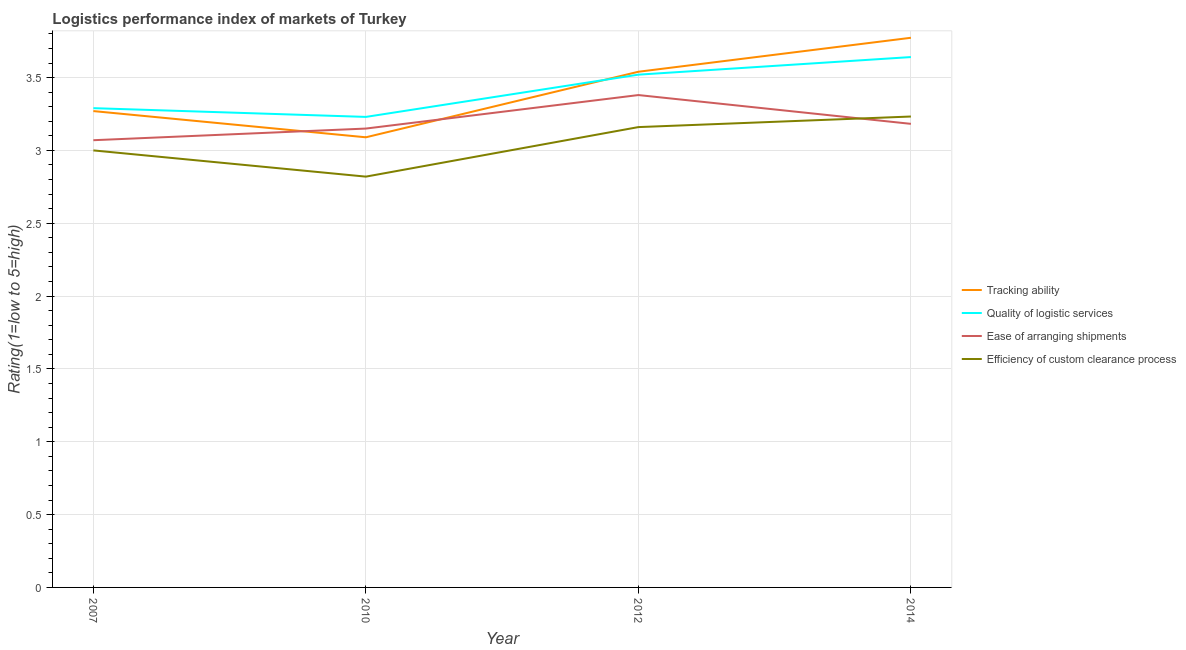Is the number of lines equal to the number of legend labels?
Your answer should be very brief. Yes. What is the lpi rating of efficiency of custom clearance process in 2012?
Offer a terse response. 3.16. Across all years, what is the maximum lpi rating of ease of arranging shipments?
Give a very brief answer. 3.38. Across all years, what is the minimum lpi rating of efficiency of custom clearance process?
Your answer should be compact. 2.82. In which year was the lpi rating of efficiency of custom clearance process maximum?
Offer a terse response. 2014. In which year was the lpi rating of quality of logistic services minimum?
Make the answer very short. 2010. What is the total lpi rating of quality of logistic services in the graph?
Provide a short and direct response. 13.68. What is the difference between the lpi rating of quality of logistic services in 2010 and that in 2012?
Make the answer very short. -0.29. What is the difference between the lpi rating of ease of arranging shipments in 2014 and the lpi rating of quality of logistic services in 2010?
Offer a very short reply. -0.05. What is the average lpi rating of ease of arranging shipments per year?
Your answer should be compact. 3.2. In the year 2014, what is the difference between the lpi rating of tracking ability and lpi rating of ease of arranging shipments?
Your answer should be compact. 0.59. What is the ratio of the lpi rating of ease of arranging shipments in 2010 to that in 2014?
Offer a terse response. 0.99. What is the difference between the highest and the second highest lpi rating of ease of arranging shipments?
Ensure brevity in your answer.  0.2. What is the difference between the highest and the lowest lpi rating of ease of arranging shipments?
Offer a terse response. 0.31. Is the sum of the lpi rating of ease of arranging shipments in 2007 and 2010 greater than the maximum lpi rating of quality of logistic services across all years?
Offer a terse response. Yes. Is it the case that in every year, the sum of the lpi rating of efficiency of custom clearance process and lpi rating of quality of logistic services is greater than the sum of lpi rating of tracking ability and lpi rating of ease of arranging shipments?
Your answer should be compact. No. Does the lpi rating of ease of arranging shipments monotonically increase over the years?
Ensure brevity in your answer.  No. How many lines are there?
Make the answer very short. 4. How many years are there in the graph?
Offer a terse response. 4. Are the values on the major ticks of Y-axis written in scientific E-notation?
Make the answer very short. No. Does the graph contain any zero values?
Give a very brief answer. No. Does the graph contain grids?
Your answer should be very brief. Yes. What is the title of the graph?
Offer a terse response. Logistics performance index of markets of Turkey. Does "Subsidies and Transfers" appear as one of the legend labels in the graph?
Keep it short and to the point. No. What is the label or title of the Y-axis?
Keep it short and to the point. Rating(1=low to 5=high). What is the Rating(1=low to 5=high) in Tracking ability in 2007?
Offer a terse response. 3.27. What is the Rating(1=low to 5=high) in Quality of logistic services in 2007?
Make the answer very short. 3.29. What is the Rating(1=low to 5=high) in Ease of arranging shipments in 2007?
Your response must be concise. 3.07. What is the Rating(1=low to 5=high) of Efficiency of custom clearance process in 2007?
Your answer should be compact. 3. What is the Rating(1=low to 5=high) in Tracking ability in 2010?
Offer a terse response. 3.09. What is the Rating(1=low to 5=high) in Quality of logistic services in 2010?
Your response must be concise. 3.23. What is the Rating(1=low to 5=high) of Ease of arranging shipments in 2010?
Provide a short and direct response. 3.15. What is the Rating(1=low to 5=high) of Efficiency of custom clearance process in 2010?
Provide a succinct answer. 2.82. What is the Rating(1=low to 5=high) in Tracking ability in 2012?
Keep it short and to the point. 3.54. What is the Rating(1=low to 5=high) in Quality of logistic services in 2012?
Offer a very short reply. 3.52. What is the Rating(1=low to 5=high) in Ease of arranging shipments in 2012?
Your answer should be very brief. 3.38. What is the Rating(1=low to 5=high) in Efficiency of custom clearance process in 2012?
Keep it short and to the point. 3.16. What is the Rating(1=low to 5=high) of Tracking ability in 2014?
Offer a terse response. 3.77. What is the Rating(1=low to 5=high) in Quality of logistic services in 2014?
Offer a very short reply. 3.64. What is the Rating(1=low to 5=high) in Ease of arranging shipments in 2014?
Your answer should be compact. 3.18. What is the Rating(1=low to 5=high) in Efficiency of custom clearance process in 2014?
Provide a short and direct response. 3.23. Across all years, what is the maximum Rating(1=low to 5=high) in Tracking ability?
Your response must be concise. 3.77. Across all years, what is the maximum Rating(1=low to 5=high) in Quality of logistic services?
Your response must be concise. 3.64. Across all years, what is the maximum Rating(1=low to 5=high) of Ease of arranging shipments?
Your answer should be very brief. 3.38. Across all years, what is the maximum Rating(1=low to 5=high) in Efficiency of custom clearance process?
Make the answer very short. 3.23. Across all years, what is the minimum Rating(1=low to 5=high) of Tracking ability?
Ensure brevity in your answer.  3.09. Across all years, what is the minimum Rating(1=low to 5=high) in Quality of logistic services?
Provide a short and direct response. 3.23. Across all years, what is the minimum Rating(1=low to 5=high) in Ease of arranging shipments?
Give a very brief answer. 3.07. Across all years, what is the minimum Rating(1=low to 5=high) in Efficiency of custom clearance process?
Offer a terse response. 2.82. What is the total Rating(1=low to 5=high) in Tracking ability in the graph?
Give a very brief answer. 13.67. What is the total Rating(1=low to 5=high) of Quality of logistic services in the graph?
Provide a succinct answer. 13.68. What is the total Rating(1=low to 5=high) of Ease of arranging shipments in the graph?
Offer a terse response. 12.78. What is the total Rating(1=low to 5=high) in Efficiency of custom clearance process in the graph?
Provide a succinct answer. 12.21. What is the difference between the Rating(1=low to 5=high) of Tracking ability in 2007 and that in 2010?
Provide a short and direct response. 0.18. What is the difference between the Rating(1=low to 5=high) in Quality of logistic services in 2007 and that in 2010?
Offer a very short reply. 0.06. What is the difference between the Rating(1=low to 5=high) in Ease of arranging shipments in 2007 and that in 2010?
Offer a terse response. -0.08. What is the difference between the Rating(1=low to 5=high) in Efficiency of custom clearance process in 2007 and that in 2010?
Keep it short and to the point. 0.18. What is the difference between the Rating(1=low to 5=high) of Tracking ability in 2007 and that in 2012?
Make the answer very short. -0.27. What is the difference between the Rating(1=low to 5=high) in Quality of logistic services in 2007 and that in 2012?
Offer a terse response. -0.23. What is the difference between the Rating(1=low to 5=high) in Ease of arranging shipments in 2007 and that in 2012?
Keep it short and to the point. -0.31. What is the difference between the Rating(1=low to 5=high) in Efficiency of custom clearance process in 2007 and that in 2012?
Your answer should be very brief. -0.16. What is the difference between the Rating(1=low to 5=high) in Tracking ability in 2007 and that in 2014?
Your answer should be compact. -0.5. What is the difference between the Rating(1=low to 5=high) of Quality of logistic services in 2007 and that in 2014?
Your answer should be very brief. -0.35. What is the difference between the Rating(1=low to 5=high) of Ease of arranging shipments in 2007 and that in 2014?
Your answer should be very brief. -0.11. What is the difference between the Rating(1=low to 5=high) in Efficiency of custom clearance process in 2007 and that in 2014?
Ensure brevity in your answer.  -0.23. What is the difference between the Rating(1=low to 5=high) in Tracking ability in 2010 and that in 2012?
Keep it short and to the point. -0.45. What is the difference between the Rating(1=low to 5=high) in Quality of logistic services in 2010 and that in 2012?
Keep it short and to the point. -0.29. What is the difference between the Rating(1=low to 5=high) of Ease of arranging shipments in 2010 and that in 2012?
Ensure brevity in your answer.  -0.23. What is the difference between the Rating(1=low to 5=high) in Efficiency of custom clearance process in 2010 and that in 2012?
Keep it short and to the point. -0.34. What is the difference between the Rating(1=low to 5=high) of Tracking ability in 2010 and that in 2014?
Make the answer very short. -0.68. What is the difference between the Rating(1=low to 5=high) in Quality of logistic services in 2010 and that in 2014?
Provide a succinct answer. -0.41. What is the difference between the Rating(1=low to 5=high) in Ease of arranging shipments in 2010 and that in 2014?
Your response must be concise. -0.03. What is the difference between the Rating(1=low to 5=high) in Efficiency of custom clearance process in 2010 and that in 2014?
Your answer should be very brief. -0.41. What is the difference between the Rating(1=low to 5=high) of Tracking ability in 2012 and that in 2014?
Offer a very short reply. -0.23. What is the difference between the Rating(1=low to 5=high) in Quality of logistic services in 2012 and that in 2014?
Your answer should be very brief. -0.12. What is the difference between the Rating(1=low to 5=high) in Ease of arranging shipments in 2012 and that in 2014?
Provide a succinct answer. 0.2. What is the difference between the Rating(1=low to 5=high) of Efficiency of custom clearance process in 2012 and that in 2014?
Ensure brevity in your answer.  -0.07. What is the difference between the Rating(1=low to 5=high) of Tracking ability in 2007 and the Rating(1=low to 5=high) of Ease of arranging shipments in 2010?
Your answer should be very brief. 0.12. What is the difference between the Rating(1=low to 5=high) in Tracking ability in 2007 and the Rating(1=low to 5=high) in Efficiency of custom clearance process in 2010?
Ensure brevity in your answer.  0.45. What is the difference between the Rating(1=low to 5=high) in Quality of logistic services in 2007 and the Rating(1=low to 5=high) in Ease of arranging shipments in 2010?
Your response must be concise. 0.14. What is the difference between the Rating(1=low to 5=high) in Quality of logistic services in 2007 and the Rating(1=low to 5=high) in Efficiency of custom clearance process in 2010?
Your answer should be compact. 0.47. What is the difference between the Rating(1=low to 5=high) of Ease of arranging shipments in 2007 and the Rating(1=low to 5=high) of Efficiency of custom clearance process in 2010?
Give a very brief answer. 0.25. What is the difference between the Rating(1=low to 5=high) in Tracking ability in 2007 and the Rating(1=low to 5=high) in Ease of arranging shipments in 2012?
Your response must be concise. -0.11. What is the difference between the Rating(1=low to 5=high) in Tracking ability in 2007 and the Rating(1=low to 5=high) in Efficiency of custom clearance process in 2012?
Provide a short and direct response. 0.11. What is the difference between the Rating(1=low to 5=high) in Quality of logistic services in 2007 and the Rating(1=low to 5=high) in Ease of arranging shipments in 2012?
Your answer should be compact. -0.09. What is the difference between the Rating(1=low to 5=high) in Quality of logistic services in 2007 and the Rating(1=low to 5=high) in Efficiency of custom clearance process in 2012?
Your answer should be very brief. 0.13. What is the difference between the Rating(1=low to 5=high) of Ease of arranging shipments in 2007 and the Rating(1=low to 5=high) of Efficiency of custom clearance process in 2012?
Make the answer very short. -0.09. What is the difference between the Rating(1=low to 5=high) of Tracking ability in 2007 and the Rating(1=low to 5=high) of Quality of logistic services in 2014?
Keep it short and to the point. -0.37. What is the difference between the Rating(1=low to 5=high) in Tracking ability in 2007 and the Rating(1=low to 5=high) in Ease of arranging shipments in 2014?
Provide a short and direct response. 0.09. What is the difference between the Rating(1=low to 5=high) of Tracking ability in 2007 and the Rating(1=low to 5=high) of Efficiency of custom clearance process in 2014?
Provide a succinct answer. 0.04. What is the difference between the Rating(1=low to 5=high) of Quality of logistic services in 2007 and the Rating(1=low to 5=high) of Ease of arranging shipments in 2014?
Keep it short and to the point. 0.11. What is the difference between the Rating(1=low to 5=high) in Quality of logistic services in 2007 and the Rating(1=low to 5=high) in Efficiency of custom clearance process in 2014?
Your answer should be compact. 0.06. What is the difference between the Rating(1=low to 5=high) in Ease of arranging shipments in 2007 and the Rating(1=low to 5=high) in Efficiency of custom clearance process in 2014?
Your answer should be very brief. -0.16. What is the difference between the Rating(1=low to 5=high) in Tracking ability in 2010 and the Rating(1=low to 5=high) in Quality of logistic services in 2012?
Offer a terse response. -0.43. What is the difference between the Rating(1=low to 5=high) of Tracking ability in 2010 and the Rating(1=low to 5=high) of Ease of arranging shipments in 2012?
Give a very brief answer. -0.29. What is the difference between the Rating(1=low to 5=high) in Tracking ability in 2010 and the Rating(1=low to 5=high) in Efficiency of custom clearance process in 2012?
Your answer should be very brief. -0.07. What is the difference between the Rating(1=low to 5=high) in Quality of logistic services in 2010 and the Rating(1=low to 5=high) in Efficiency of custom clearance process in 2012?
Keep it short and to the point. 0.07. What is the difference between the Rating(1=low to 5=high) of Ease of arranging shipments in 2010 and the Rating(1=low to 5=high) of Efficiency of custom clearance process in 2012?
Offer a very short reply. -0.01. What is the difference between the Rating(1=low to 5=high) of Tracking ability in 2010 and the Rating(1=low to 5=high) of Quality of logistic services in 2014?
Provide a succinct answer. -0.55. What is the difference between the Rating(1=low to 5=high) of Tracking ability in 2010 and the Rating(1=low to 5=high) of Ease of arranging shipments in 2014?
Ensure brevity in your answer.  -0.09. What is the difference between the Rating(1=low to 5=high) of Tracking ability in 2010 and the Rating(1=low to 5=high) of Efficiency of custom clearance process in 2014?
Give a very brief answer. -0.14. What is the difference between the Rating(1=low to 5=high) of Quality of logistic services in 2010 and the Rating(1=low to 5=high) of Ease of arranging shipments in 2014?
Offer a terse response. 0.05. What is the difference between the Rating(1=low to 5=high) in Quality of logistic services in 2010 and the Rating(1=low to 5=high) in Efficiency of custom clearance process in 2014?
Keep it short and to the point. -0. What is the difference between the Rating(1=low to 5=high) in Ease of arranging shipments in 2010 and the Rating(1=low to 5=high) in Efficiency of custom clearance process in 2014?
Your answer should be compact. -0.08. What is the difference between the Rating(1=low to 5=high) in Tracking ability in 2012 and the Rating(1=low to 5=high) in Quality of logistic services in 2014?
Give a very brief answer. -0.1. What is the difference between the Rating(1=low to 5=high) in Tracking ability in 2012 and the Rating(1=low to 5=high) in Ease of arranging shipments in 2014?
Offer a very short reply. 0.36. What is the difference between the Rating(1=low to 5=high) in Tracking ability in 2012 and the Rating(1=low to 5=high) in Efficiency of custom clearance process in 2014?
Offer a terse response. 0.31. What is the difference between the Rating(1=low to 5=high) of Quality of logistic services in 2012 and the Rating(1=low to 5=high) of Ease of arranging shipments in 2014?
Your answer should be very brief. 0.34. What is the difference between the Rating(1=low to 5=high) in Quality of logistic services in 2012 and the Rating(1=low to 5=high) in Efficiency of custom clearance process in 2014?
Your answer should be very brief. 0.29. What is the difference between the Rating(1=low to 5=high) of Ease of arranging shipments in 2012 and the Rating(1=low to 5=high) of Efficiency of custom clearance process in 2014?
Provide a short and direct response. 0.15. What is the average Rating(1=low to 5=high) in Tracking ability per year?
Provide a short and direct response. 3.42. What is the average Rating(1=low to 5=high) in Quality of logistic services per year?
Your answer should be compact. 3.42. What is the average Rating(1=low to 5=high) in Ease of arranging shipments per year?
Your answer should be very brief. 3.2. What is the average Rating(1=low to 5=high) in Efficiency of custom clearance process per year?
Provide a succinct answer. 3.05. In the year 2007, what is the difference between the Rating(1=low to 5=high) in Tracking ability and Rating(1=low to 5=high) in Quality of logistic services?
Provide a short and direct response. -0.02. In the year 2007, what is the difference between the Rating(1=low to 5=high) of Tracking ability and Rating(1=low to 5=high) of Efficiency of custom clearance process?
Your answer should be very brief. 0.27. In the year 2007, what is the difference between the Rating(1=low to 5=high) in Quality of logistic services and Rating(1=low to 5=high) in Ease of arranging shipments?
Provide a short and direct response. 0.22. In the year 2007, what is the difference between the Rating(1=low to 5=high) of Quality of logistic services and Rating(1=low to 5=high) of Efficiency of custom clearance process?
Keep it short and to the point. 0.29. In the year 2007, what is the difference between the Rating(1=low to 5=high) of Ease of arranging shipments and Rating(1=low to 5=high) of Efficiency of custom clearance process?
Provide a succinct answer. 0.07. In the year 2010, what is the difference between the Rating(1=low to 5=high) of Tracking ability and Rating(1=low to 5=high) of Quality of logistic services?
Keep it short and to the point. -0.14. In the year 2010, what is the difference between the Rating(1=low to 5=high) of Tracking ability and Rating(1=low to 5=high) of Ease of arranging shipments?
Provide a short and direct response. -0.06. In the year 2010, what is the difference between the Rating(1=low to 5=high) of Tracking ability and Rating(1=low to 5=high) of Efficiency of custom clearance process?
Ensure brevity in your answer.  0.27. In the year 2010, what is the difference between the Rating(1=low to 5=high) in Quality of logistic services and Rating(1=low to 5=high) in Ease of arranging shipments?
Your answer should be compact. 0.08. In the year 2010, what is the difference between the Rating(1=low to 5=high) in Quality of logistic services and Rating(1=low to 5=high) in Efficiency of custom clearance process?
Ensure brevity in your answer.  0.41. In the year 2010, what is the difference between the Rating(1=low to 5=high) of Ease of arranging shipments and Rating(1=low to 5=high) of Efficiency of custom clearance process?
Keep it short and to the point. 0.33. In the year 2012, what is the difference between the Rating(1=low to 5=high) in Tracking ability and Rating(1=low to 5=high) in Quality of logistic services?
Offer a very short reply. 0.02. In the year 2012, what is the difference between the Rating(1=low to 5=high) of Tracking ability and Rating(1=low to 5=high) of Ease of arranging shipments?
Make the answer very short. 0.16. In the year 2012, what is the difference between the Rating(1=low to 5=high) in Tracking ability and Rating(1=low to 5=high) in Efficiency of custom clearance process?
Ensure brevity in your answer.  0.38. In the year 2012, what is the difference between the Rating(1=low to 5=high) in Quality of logistic services and Rating(1=low to 5=high) in Ease of arranging shipments?
Your answer should be compact. 0.14. In the year 2012, what is the difference between the Rating(1=low to 5=high) of Quality of logistic services and Rating(1=low to 5=high) of Efficiency of custom clearance process?
Provide a short and direct response. 0.36. In the year 2012, what is the difference between the Rating(1=low to 5=high) in Ease of arranging shipments and Rating(1=low to 5=high) in Efficiency of custom clearance process?
Give a very brief answer. 0.22. In the year 2014, what is the difference between the Rating(1=low to 5=high) in Tracking ability and Rating(1=low to 5=high) in Quality of logistic services?
Offer a very short reply. 0.13. In the year 2014, what is the difference between the Rating(1=low to 5=high) in Tracking ability and Rating(1=low to 5=high) in Ease of arranging shipments?
Keep it short and to the point. 0.59. In the year 2014, what is the difference between the Rating(1=low to 5=high) of Tracking ability and Rating(1=low to 5=high) of Efficiency of custom clearance process?
Make the answer very short. 0.54. In the year 2014, what is the difference between the Rating(1=low to 5=high) of Quality of logistic services and Rating(1=low to 5=high) of Ease of arranging shipments?
Ensure brevity in your answer.  0.46. In the year 2014, what is the difference between the Rating(1=low to 5=high) in Quality of logistic services and Rating(1=low to 5=high) in Efficiency of custom clearance process?
Provide a succinct answer. 0.41. In the year 2014, what is the difference between the Rating(1=low to 5=high) of Ease of arranging shipments and Rating(1=low to 5=high) of Efficiency of custom clearance process?
Offer a very short reply. -0.05. What is the ratio of the Rating(1=low to 5=high) of Tracking ability in 2007 to that in 2010?
Provide a short and direct response. 1.06. What is the ratio of the Rating(1=low to 5=high) in Quality of logistic services in 2007 to that in 2010?
Keep it short and to the point. 1.02. What is the ratio of the Rating(1=low to 5=high) of Ease of arranging shipments in 2007 to that in 2010?
Provide a succinct answer. 0.97. What is the ratio of the Rating(1=low to 5=high) of Efficiency of custom clearance process in 2007 to that in 2010?
Keep it short and to the point. 1.06. What is the ratio of the Rating(1=low to 5=high) of Tracking ability in 2007 to that in 2012?
Ensure brevity in your answer.  0.92. What is the ratio of the Rating(1=low to 5=high) of Quality of logistic services in 2007 to that in 2012?
Offer a terse response. 0.93. What is the ratio of the Rating(1=low to 5=high) in Ease of arranging shipments in 2007 to that in 2012?
Your answer should be compact. 0.91. What is the ratio of the Rating(1=low to 5=high) of Efficiency of custom clearance process in 2007 to that in 2012?
Ensure brevity in your answer.  0.95. What is the ratio of the Rating(1=low to 5=high) in Tracking ability in 2007 to that in 2014?
Your response must be concise. 0.87. What is the ratio of the Rating(1=low to 5=high) of Quality of logistic services in 2007 to that in 2014?
Your answer should be compact. 0.9. What is the ratio of the Rating(1=low to 5=high) in Ease of arranging shipments in 2007 to that in 2014?
Ensure brevity in your answer.  0.96. What is the ratio of the Rating(1=low to 5=high) in Efficiency of custom clearance process in 2007 to that in 2014?
Ensure brevity in your answer.  0.93. What is the ratio of the Rating(1=low to 5=high) of Tracking ability in 2010 to that in 2012?
Give a very brief answer. 0.87. What is the ratio of the Rating(1=low to 5=high) of Quality of logistic services in 2010 to that in 2012?
Ensure brevity in your answer.  0.92. What is the ratio of the Rating(1=low to 5=high) of Ease of arranging shipments in 2010 to that in 2012?
Your answer should be very brief. 0.93. What is the ratio of the Rating(1=low to 5=high) of Efficiency of custom clearance process in 2010 to that in 2012?
Keep it short and to the point. 0.89. What is the ratio of the Rating(1=low to 5=high) in Tracking ability in 2010 to that in 2014?
Give a very brief answer. 0.82. What is the ratio of the Rating(1=low to 5=high) in Quality of logistic services in 2010 to that in 2014?
Give a very brief answer. 0.89. What is the ratio of the Rating(1=low to 5=high) of Ease of arranging shipments in 2010 to that in 2014?
Your answer should be very brief. 0.99. What is the ratio of the Rating(1=low to 5=high) of Efficiency of custom clearance process in 2010 to that in 2014?
Your response must be concise. 0.87. What is the ratio of the Rating(1=low to 5=high) in Tracking ability in 2012 to that in 2014?
Your answer should be very brief. 0.94. What is the ratio of the Rating(1=low to 5=high) of Quality of logistic services in 2012 to that in 2014?
Keep it short and to the point. 0.97. What is the ratio of the Rating(1=low to 5=high) in Ease of arranging shipments in 2012 to that in 2014?
Give a very brief answer. 1.06. What is the ratio of the Rating(1=low to 5=high) in Efficiency of custom clearance process in 2012 to that in 2014?
Ensure brevity in your answer.  0.98. What is the difference between the highest and the second highest Rating(1=low to 5=high) in Tracking ability?
Your answer should be compact. 0.23. What is the difference between the highest and the second highest Rating(1=low to 5=high) of Quality of logistic services?
Your answer should be compact. 0.12. What is the difference between the highest and the second highest Rating(1=low to 5=high) in Ease of arranging shipments?
Offer a very short reply. 0.2. What is the difference between the highest and the second highest Rating(1=low to 5=high) of Efficiency of custom clearance process?
Give a very brief answer. 0.07. What is the difference between the highest and the lowest Rating(1=low to 5=high) of Tracking ability?
Provide a succinct answer. 0.68. What is the difference between the highest and the lowest Rating(1=low to 5=high) of Quality of logistic services?
Your response must be concise. 0.41. What is the difference between the highest and the lowest Rating(1=low to 5=high) of Ease of arranging shipments?
Keep it short and to the point. 0.31. What is the difference between the highest and the lowest Rating(1=low to 5=high) in Efficiency of custom clearance process?
Your response must be concise. 0.41. 